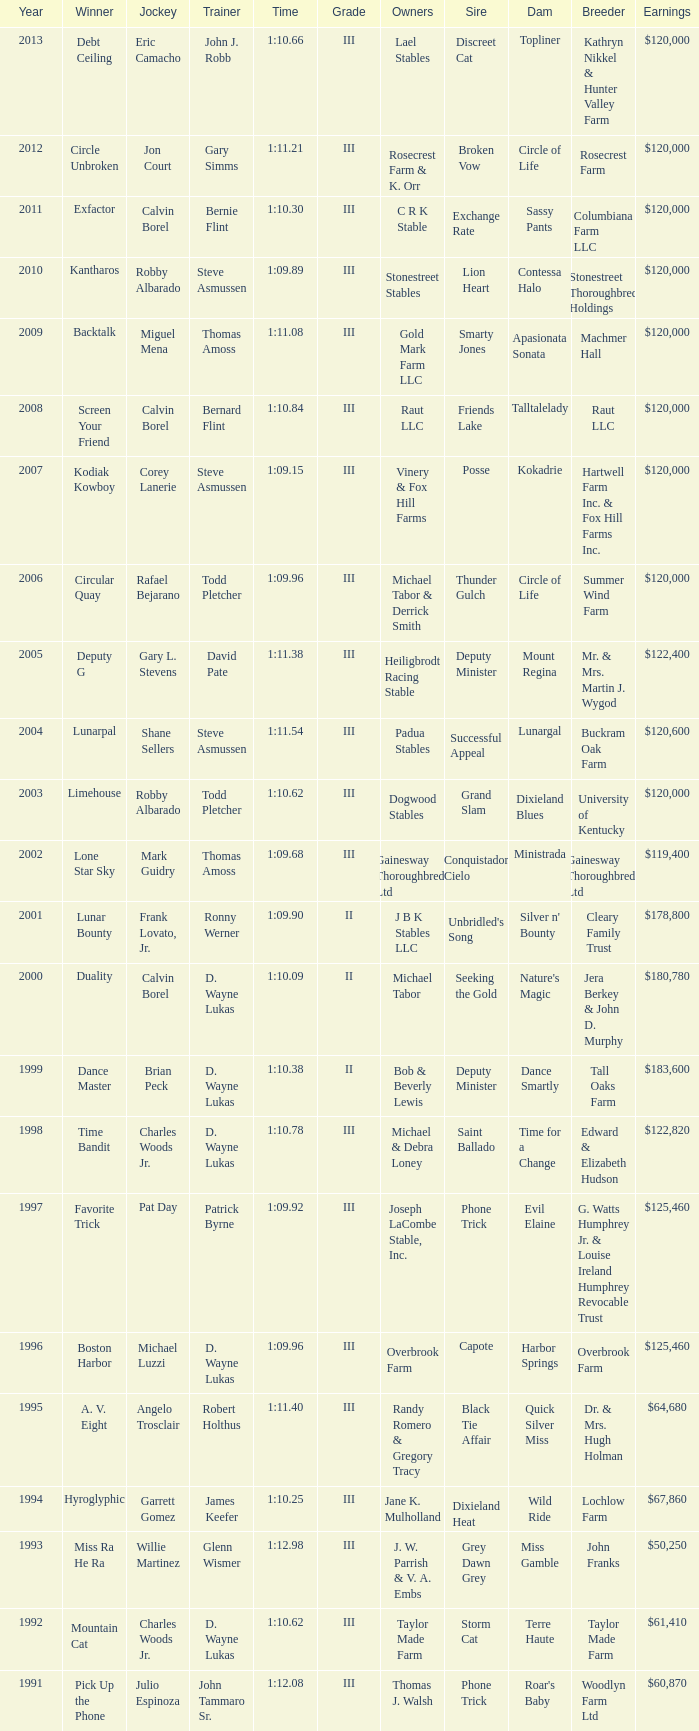Which trainer had a time of 1:10.09 with a year less than 2009? D. Wayne Lukas. 